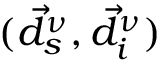Convert formula to latex. <formula><loc_0><loc_0><loc_500><loc_500>( \vec { d } _ { s } ^ { \nu } , \vec { d } _ { i } ^ { \nu } )</formula> 